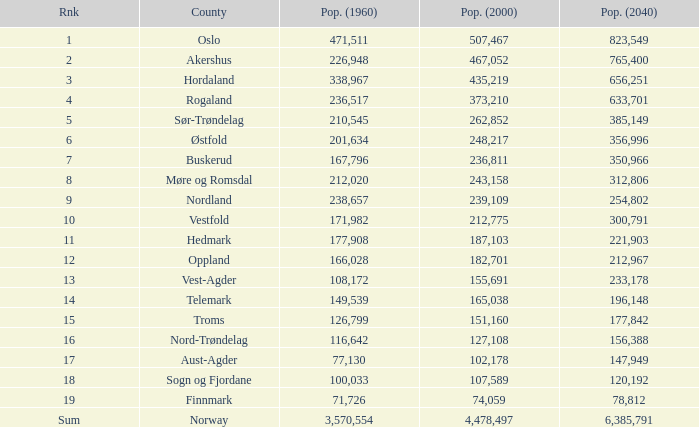What was the population of a county in 1960 that had a population of 467,052 in 2000 and 78,812 in 2040? None. 